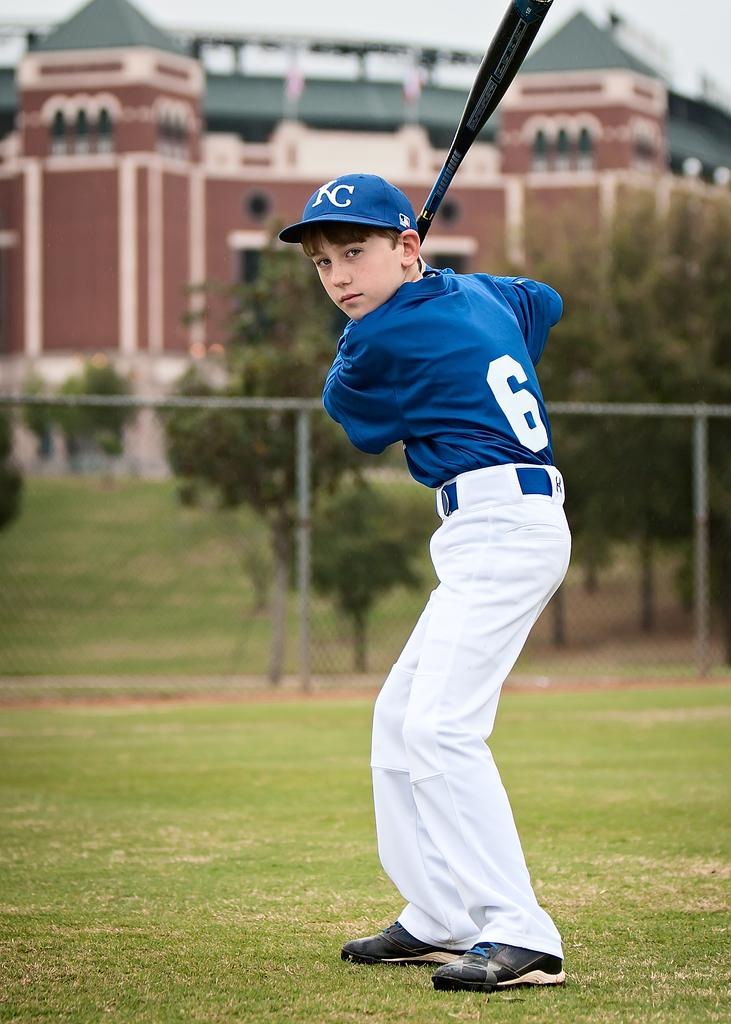<image>
Create a compact narrative representing the image presented. A young baseball player wearing a blue shirt with the number 6 on it is up to bat. 